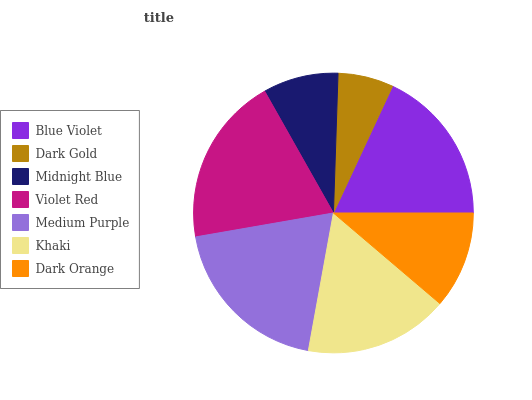Is Dark Gold the minimum?
Answer yes or no. Yes. Is Violet Red the maximum?
Answer yes or no. Yes. Is Midnight Blue the minimum?
Answer yes or no. No. Is Midnight Blue the maximum?
Answer yes or no. No. Is Midnight Blue greater than Dark Gold?
Answer yes or no. Yes. Is Dark Gold less than Midnight Blue?
Answer yes or no. Yes. Is Dark Gold greater than Midnight Blue?
Answer yes or no. No. Is Midnight Blue less than Dark Gold?
Answer yes or no. No. Is Khaki the high median?
Answer yes or no. Yes. Is Khaki the low median?
Answer yes or no. Yes. Is Dark Gold the high median?
Answer yes or no. No. Is Medium Purple the low median?
Answer yes or no. No. 